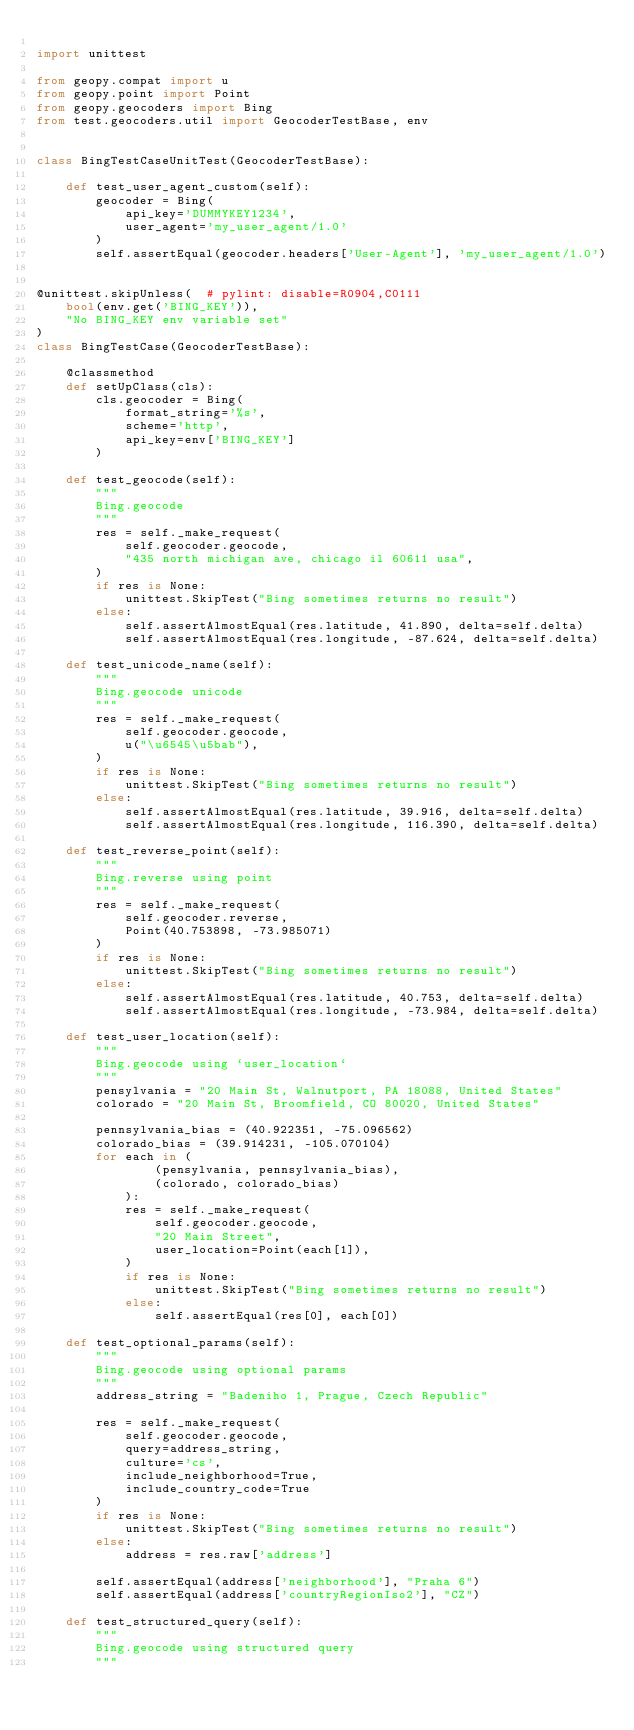Convert code to text. <code><loc_0><loc_0><loc_500><loc_500><_Python_>
import unittest

from geopy.compat import u
from geopy.point import Point
from geopy.geocoders import Bing
from test.geocoders.util import GeocoderTestBase, env


class BingTestCaseUnitTest(GeocoderTestBase):

    def test_user_agent_custom(self):
        geocoder = Bing(
            api_key='DUMMYKEY1234',
            user_agent='my_user_agent/1.0'
        )
        self.assertEqual(geocoder.headers['User-Agent'], 'my_user_agent/1.0')


@unittest.skipUnless(  # pylint: disable=R0904,C0111
    bool(env.get('BING_KEY')),
    "No BING_KEY env variable set"
)
class BingTestCase(GeocoderTestBase):

    @classmethod
    def setUpClass(cls):
        cls.geocoder = Bing(
            format_string='%s',
            scheme='http',
            api_key=env['BING_KEY']
        )

    def test_geocode(self):
        """
        Bing.geocode
        """
        res = self._make_request(
            self.geocoder.geocode,
            "435 north michigan ave, chicago il 60611 usa",
        )
        if res is None:
            unittest.SkipTest("Bing sometimes returns no result")
        else:
            self.assertAlmostEqual(res.latitude, 41.890, delta=self.delta)
            self.assertAlmostEqual(res.longitude, -87.624, delta=self.delta)

    def test_unicode_name(self):
        """
        Bing.geocode unicode
        """
        res = self._make_request(
            self.geocoder.geocode,
            u("\u6545\u5bab"),
        )
        if res is None:
            unittest.SkipTest("Bing sometimes returns no result")
        else:
            self.assertAlmostEqual(res.latitude, 39.916, delta=self.delta)
            self.assertAlmostEqual(res.longitude, 116.390, delta=self.delta)

    def test_reverse_point(self):
        """
        Bing.reverse using point
        """
        res = self._make_request(
            self.geocoder.reverse,
            Point(40.753898, -73.985071)
        )
        if res is None:
            unittest.SkipTest("Bing sometimes returns no result")
        else:
            self.assertAlmostEqual(res.latitude, 40.753, delta=self.delta)
            self.assertAlmostEqual(res.longitude, -73.984, delta=self.delta)

    def test_user_location(self):
        """
        Bing.geocode using `user_location`
        """
        pensylvania = "20 Main St, Walnutport, PA 18088, United States"
        colorado = "20 Main St, Broomfield, CO 80020, United States"

        pennsylvania_bias = (40.922351, -75.096562)
        colorado_bias = (39.914231, -105.070104)
        for each in (
                (pensylvania, pennsylvania_bias),
                (colorado, colorado_bias)
            ):
            res = self._make_request(
                self.geocoder.geocode,
                "20 Main Street",
                user_location=Point(each[1]),
            )
            if res is None:
                unittest.SkipTest("Bing sometimes returns no result")
            else:
                self.assertEqual(res[0], each[0])

    def test_optional_params(self):
        """
        Bing.geocode using optional params
        """
        address_string = "Badeniho 1, Prague, Czech Republic"

        res = self._make_request(
            self.geocoder.geocode,
            query=address_string,
            culture='cs',
            include_neighborhood=True,
            include_country_code=True
        )
        if res is None:
            unittest.SkipTest("Bing sometimes returns no result")
        else:
            address = res.raw['address']

        self.assertEqual(address['neighborhood'], "Praha 6")
        self.assertEqual(address['countryRegionIso2'], "CZ")

    def test_structured_query(self):
        """
        Bing.geocode using structured query
        """</code> 